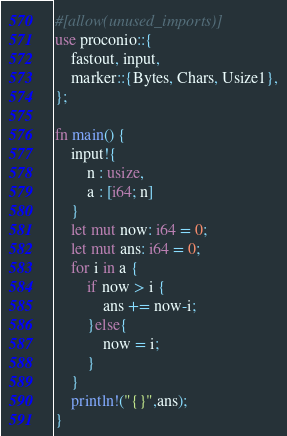<code> <loc_0><loc_0><loc_500><loc_500><_Rust_>#[allow(unused_imports)]
use proconio::{
    fastout, input,
    marker::{Bytes, Chars, Usize1},
};

fn main() {
    input!{
        n : usize,
        a : [i64; n]
    }
    let mut now: i64 = 0;
    let mut ans: i64 = 0;
    for i in a {
        if now > i {
            ans += now-i;
        }else{
            now = i;
        }
    }
    println!("{}",ans);
}
</code> 